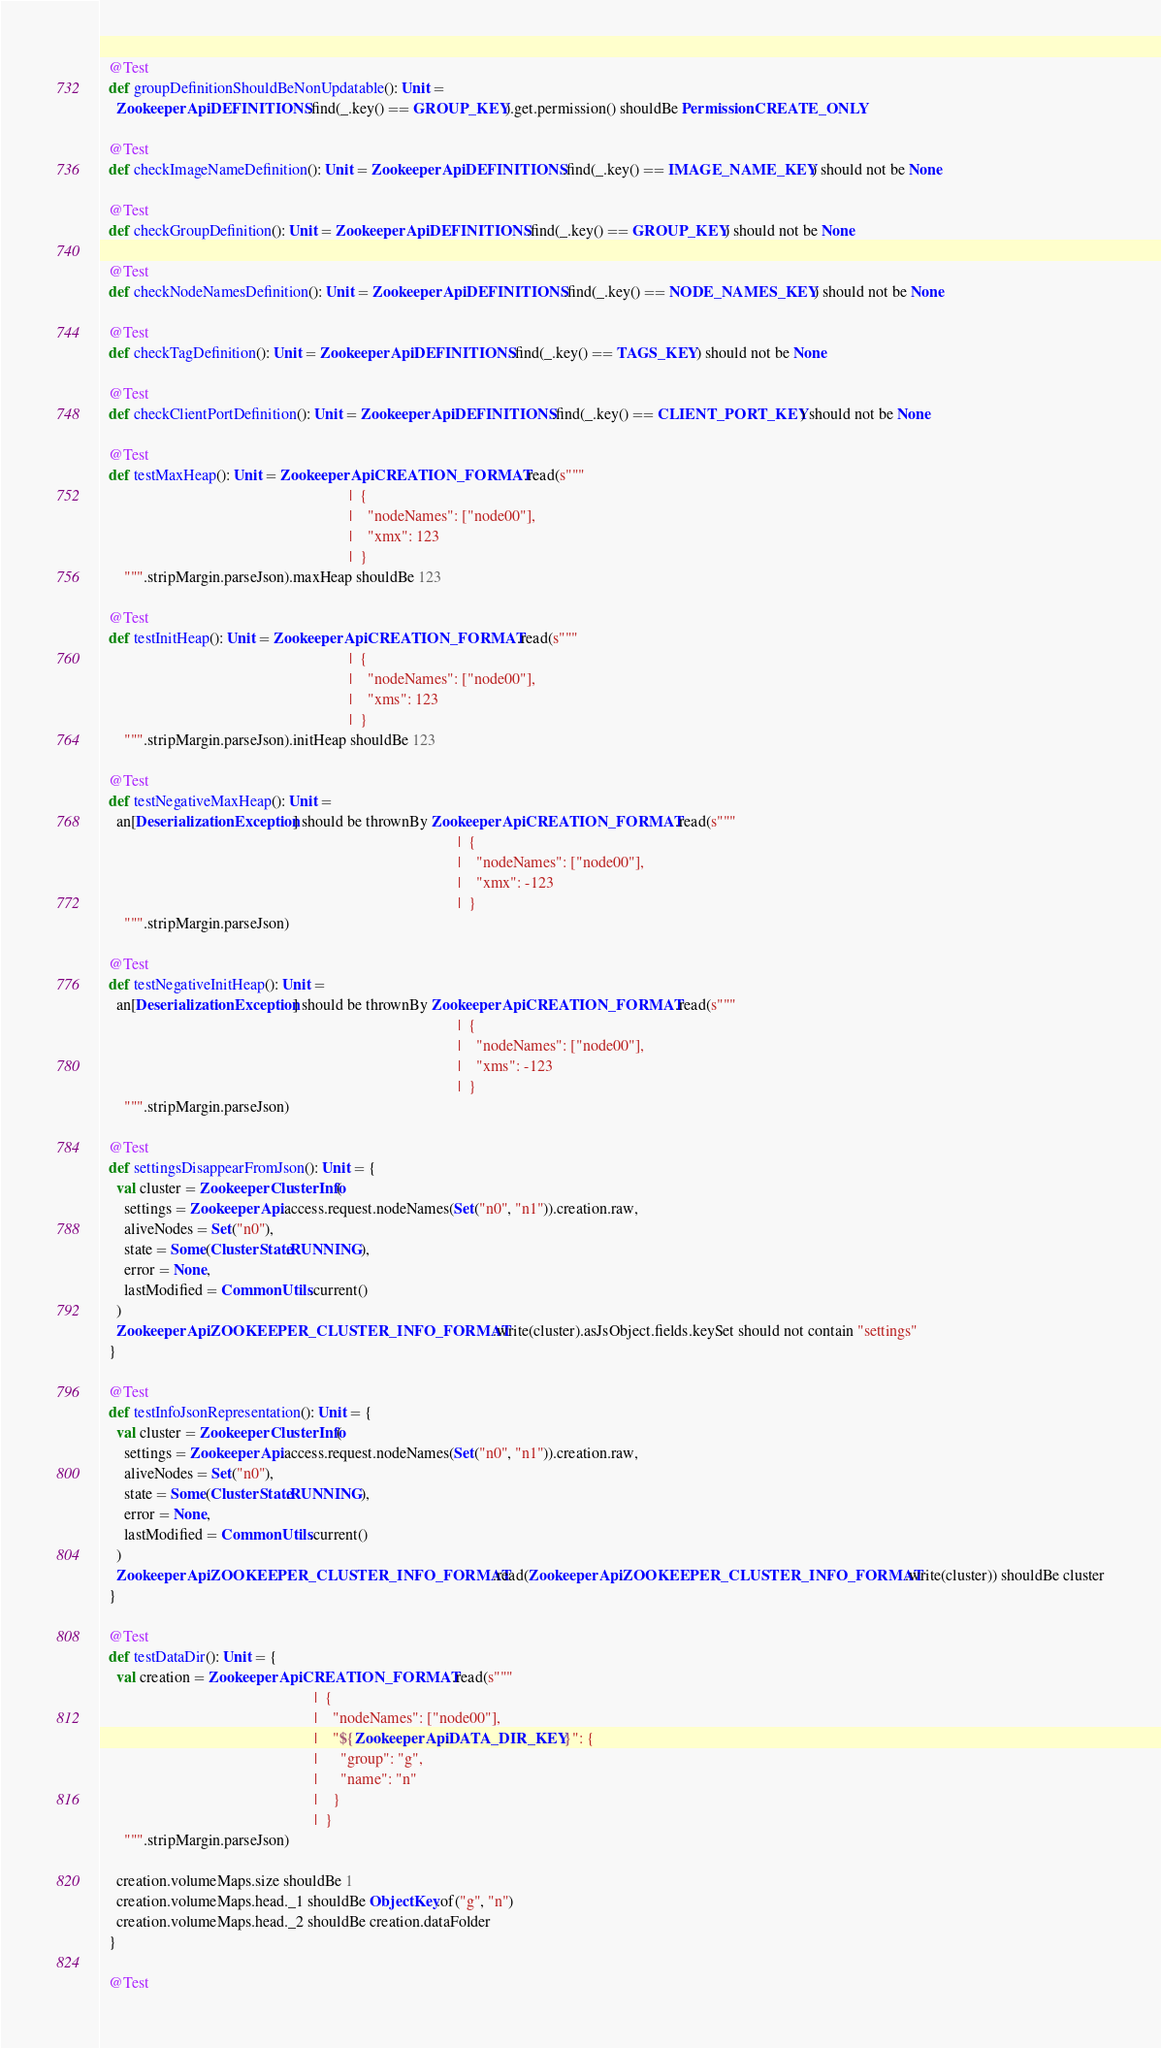<code> <loc_0><loc_0><loc_500><loc_500><_Scala_>
  @Test
  def groupDefinitionShouldBeNonUpdatable(): Unit =
    ZookeeperApi.DEFINITIONS.find(_.key() == GROUP_KEY).get.permission() shouldBe Permission.CREATE_ONLY

  @Test
  def checkImageNameDefinition(): Unit = ZookeeperApi.DEFINITIONS.find(_.key() == IMAGE_NAME_KEY) should not be None

  @Test
  def checkGroupDefinition(): Unit = ZookeeperApi.DEFINITIONS.find(_.key() == GROUP_KEY) should not be None

  @Test
  def checkNodeNamesDefinition(): Unit = ZookeeperApi.DEFINITIONS.find(_.key() == NODE_NAMES_KEY) should not be None

  @Test
  def checkTagDefinition(): Unit = ZookeeperApi.DEFINITIONS.find(_.key() == TAGS_KEY) should not be None

  @Test
  def checkClientPortDefinition(): Unit = ZookeeperApi.DEFINITIONS.find(_.key() == CLIENT_PORT_KEY) should not be None

  @Test
  def testMaxHeap(): Unit = ZookeeperApi.CREATION_FORMAT.read(s"""
                                                                |  {
                                                                |    "nodeNames": ["node00"],
                                                                |    "xmx": 123
                                                                |  }
      """.stripMargin.parseJson).maxHeap shouldBe 123

  @Test
  def testInitHeap(): Unit = ZookeeperApi.CREATION_FORMAT.read(s"""
                                                                |  {
                                                                |    "nodeNames": ["node00"],
                                                                |    "xms": 123
                                                                |  }
      """.stripMargin.parseJson).initHeap shouldBe 123

  @Test
  def testNegativeMaxHeap(): Unit =
    an[DeserializationException] should be thrownBy ZookeeperApi.CREATION_FORMAT.read(s"""
                                                                                            |  {
                                                                                            |    "nodeNames": ["node00"],
                                                                                            |    "xmx": -123
                                                                                            |  }
      """.stripMargin.parseJson)

  @Test
  def testNegativeInitHeap(): Unit =
    an[DeserializationException] should be thrownBy ZookeeperApi.CREATION_FORMAT.read(s"""
                                                                                            |  {
                                                                                            |    "nodeNames": ["node00"],
                                                                                            |    "xms": -123
                                                                                            |  }
      """.stripMargin.parseJson)

  @Test
  def settingsDisappearFromJson(): Unit = {
    val cluster = ZookeeperClusterInfo(
      settings = ZookeeperApi.access.request.nodeNames(Set("n0", "n1")).creation.raw,
      aliveNodes = Set("n0"),
      state = Some(ClusterState.RUNNING),
      error = None,
      lastModified = CommonUtils.current()
    )
    ZookeeperApi.ZOOKEEPER_CLUSTER_INFO_FORMAT.write(cluster).asJsObject.fields.keySet should not contain "settings"
  }

  @Test
  def testInfoJsonRepresentation(): Unit = {
    val cluster = ZookeeperClusterInfo(
      settings = ZookeeperApi.access.request.nodeNames(Set("n0", "n1")).creation.raw,
      aliveNodes = Set("n0"),
      state = Some(ClusterState.RUNNING),
      error = None,
      lastModified = CommonUtils.current()
    )
    ZookeeperApi.ZOOKEEPER_CLUSTER_INFO_FORMAT.read(ZookeeperApi.ZOOKEEPER_CLUSTER_INFO_FORMAT.write(cluster)) shouldBe cluster
  }

  @Test
  def testDataDir(): Unit = {
    val creation = ZookeeperApi.CREATION_FORMAT.read(s"""
                                                       |  {
                                                       |    "nodeNames": ["node00"],
                                                       |    "${ZookeeperApi.DATA_DIR_KEY}": {
                                                       |      "group": "g",
                                                       |      "name": "n"
                                                       |    }
                                                       |  }
      """.stripMargin.parseJson)

    creation.volumeMaps.size shouldBe 1
    creation.volumeMaps.head._1 shouldBe ObjectKey.of("g", "n")
    creation.volumeMaps.head._2 shouldBe creation.dataFolder
  }

  @Test</code> 